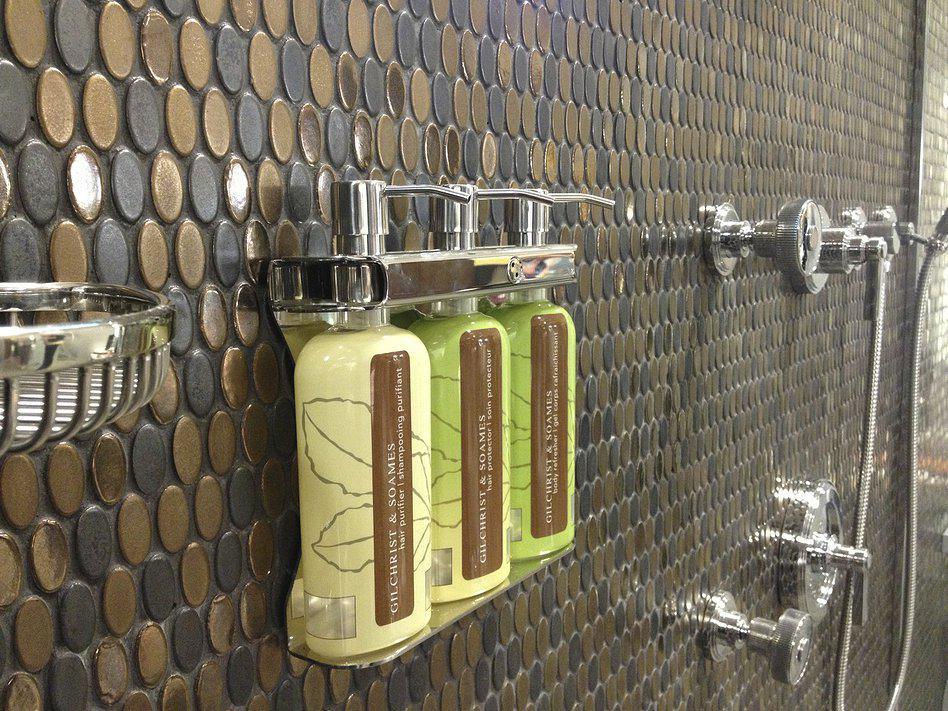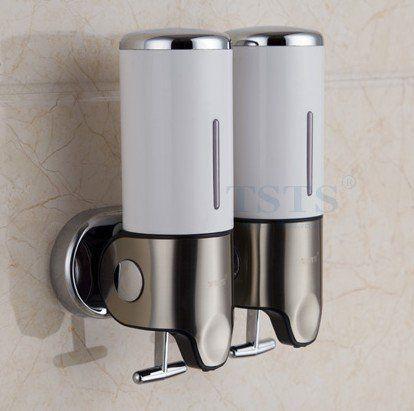The first image is the image on the left, the second image is the image on the right. For the images shown, is this caption "In one image there are two dispensers with a silver base." true? Answer yes or no. Yes. The first image is the image on the left, the second image is the image on the right. For the images displayed, is the sentence "One of the images shows a dispenser for two liquids, lotions, or soaps." factually correct? Answer yes or no. Yes. 